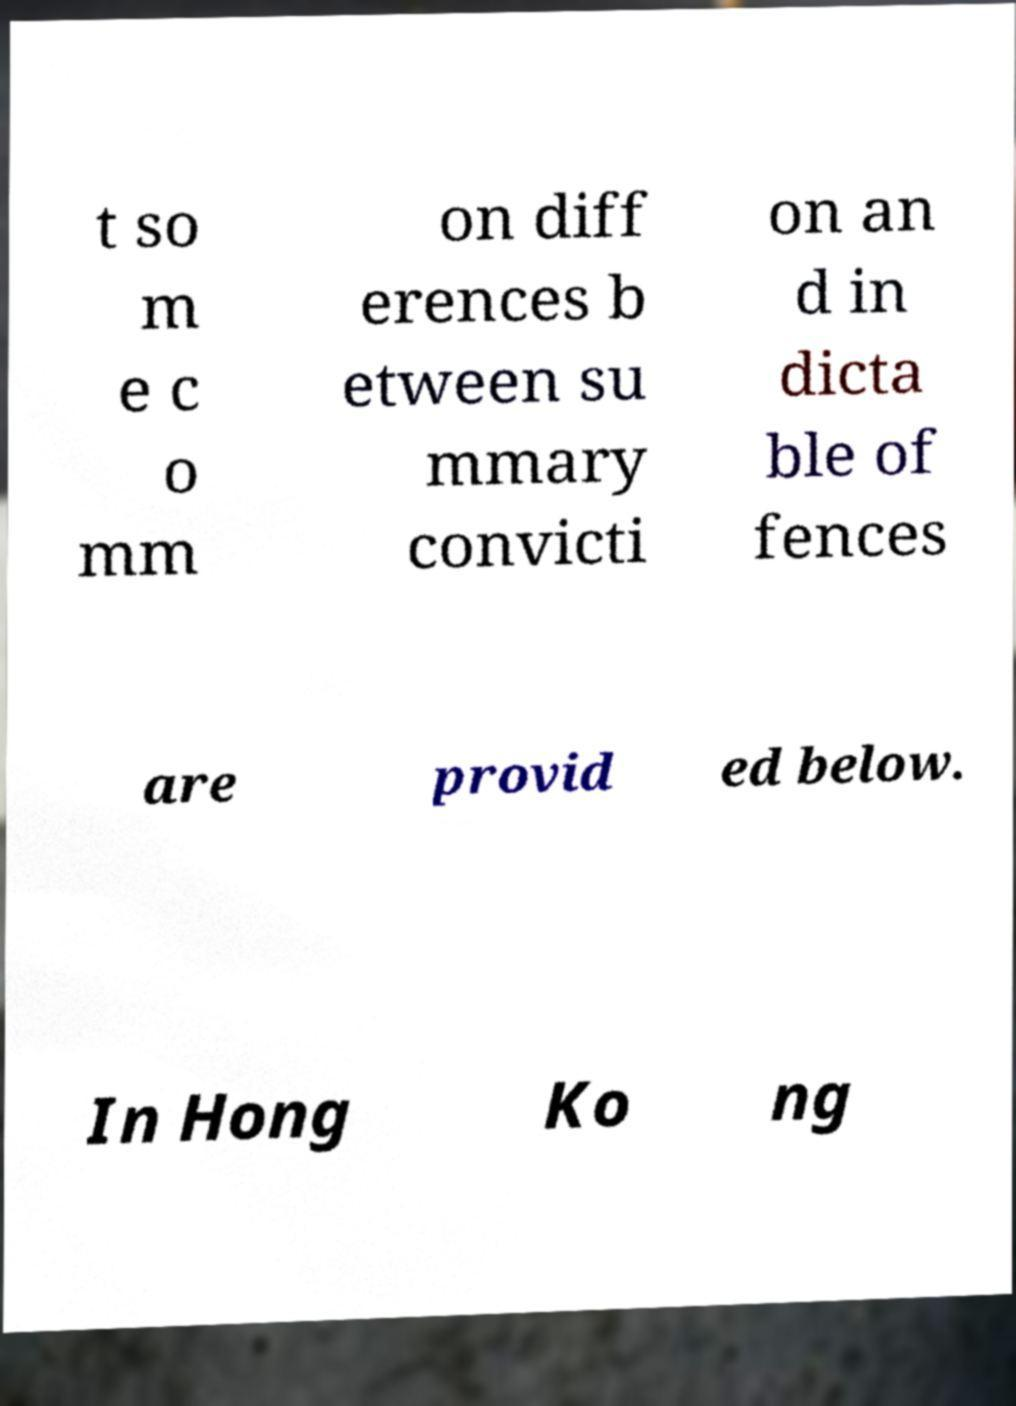Can you accurately transcribe the text from the provided image for me? t so m e c o mm on diff erences b etween su mmary convicti on an d in dicta ble of fences are provid ed below. In Hong Ko ng 